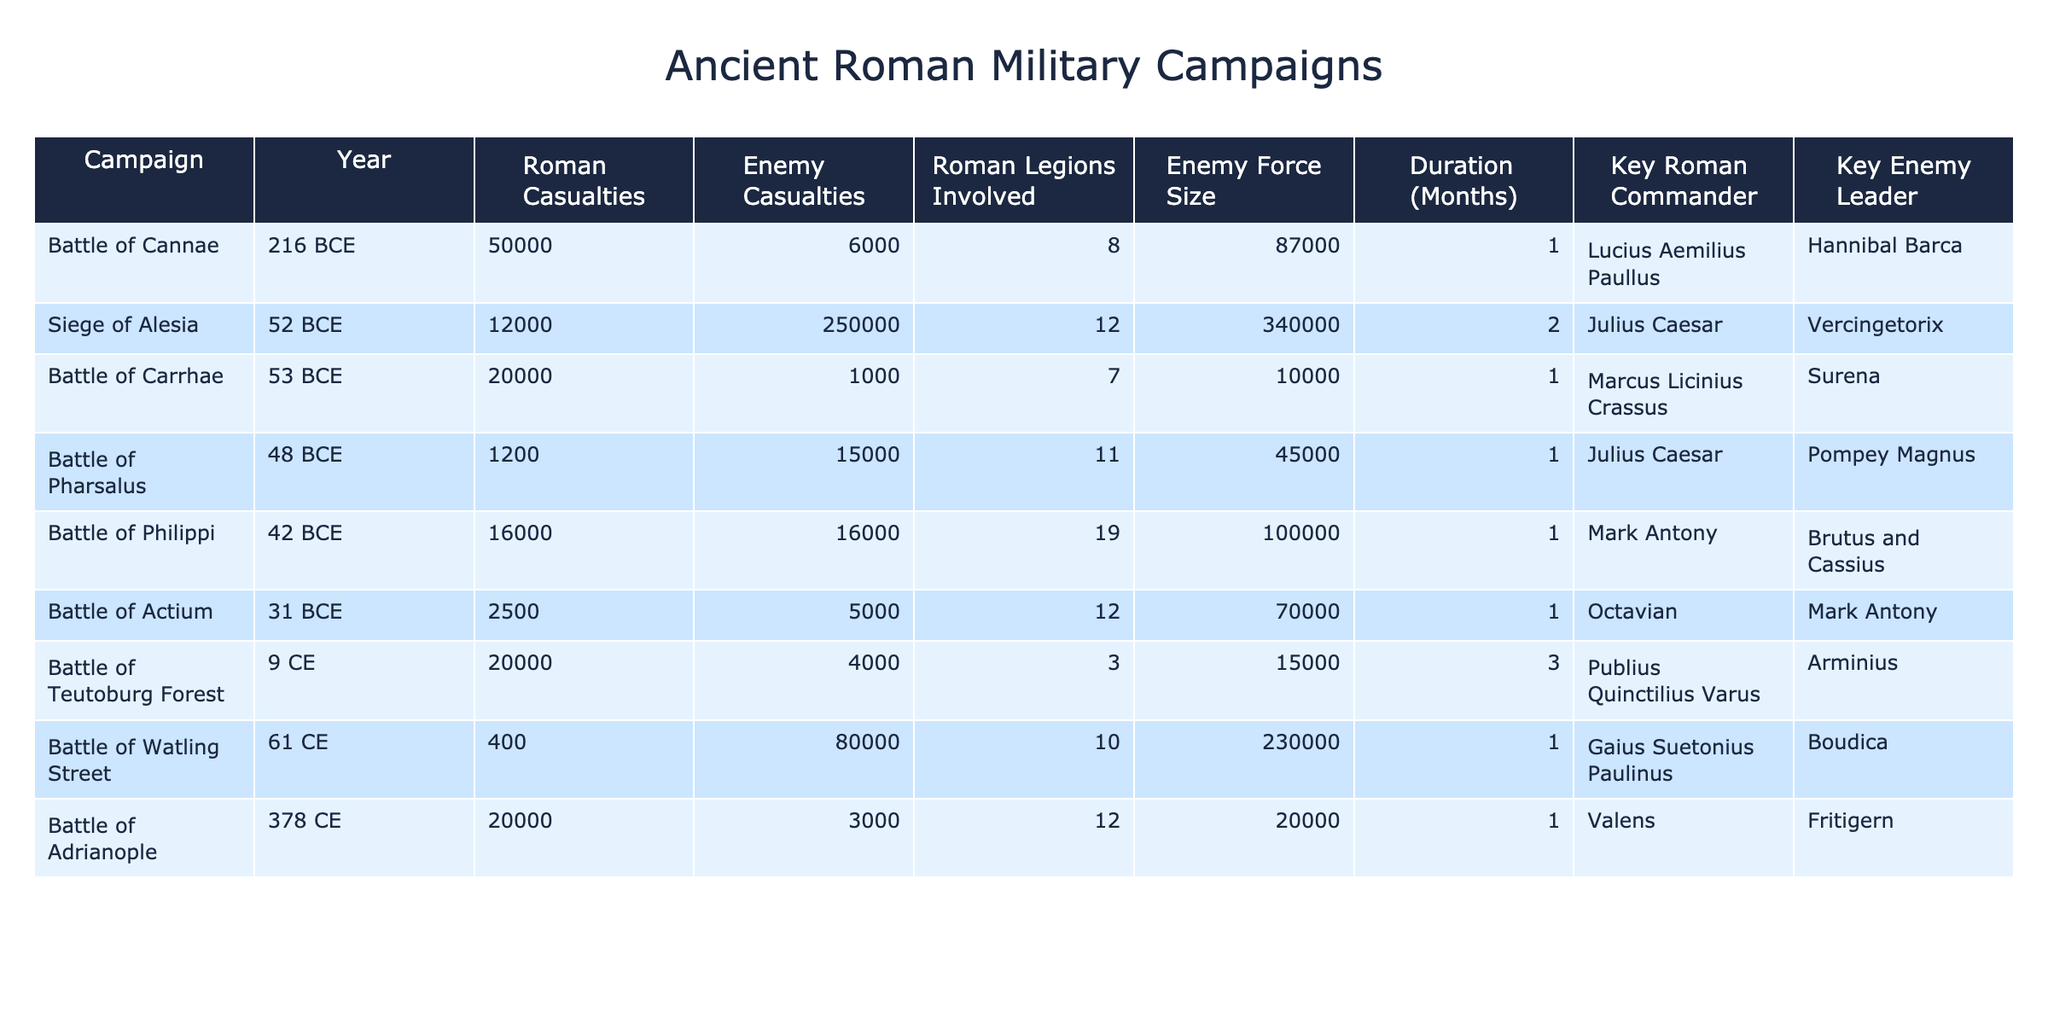What was the highest number of Roman casualties in a single campaign? By inspecting the table, the highest number of Roman casualties listed is 50,000 during the Battle of Cannae in 216 BCE.
Answer: 50,000 Which campaign had the largest enemy force size? The Siege of Alesia in 52 BCE had the largest enemy force size at 340,000 troops.
Answer: 340,000 How many Roman legions were involved in the Battle of Pharsalus? The table shows that 11 Roman legions were involved in the Battle of Pharsalus.
Answer: 11 What was the average number of enemy casualties across all campaigns? To find the average, we sum the enemy casualties: (6000 + 250000 + 1000 + 15000 + 16000 + 5000 + 4000 + 3000) = 263,000. There are 8 campaigns, so the average is 263,000 / 8 = 32,875.
Answer: 32,875 Did the Roman casualties in the Battle of Adrianople exceed those in the Siege of Alesia? Comparing the Roman casualties, the Battle of Adrianople had 20,000, while the Siege of Alesia had 12,000. Since 20,000 is greater than 12,000, yes, Roman casualties in the Battle of Adrianople exceeded those in the Siege of Alesia.
Answer: Yes Which campaign had the highest ratio of enemy casualties to Roman casualties? To find the highest ratio, we calculate the ratio for each campaign. The Siege of Alesia has the highest ratio of 250,000 enemy casualties to 12,000 Roman casualties, which gives a ratio of approximately 20.83.
Answer: Siege of Alesia What was the duration of the Battle of Teutoburg Forest? The table indicates that the duration of the Battle of Teutoburg Forest was 3 months.
Answer: 3 months Which Roman commander experienced the fewest casualties in their campaign? Looking through the table, the commander with the fewest Roman casualties is Gaius Suetonius Paulinus during the Battle of Watling Street, with only 400 casualties.
Answer: Gaius Suetonius Paulinus What percentage of enemy forces were lost in the Battle of Carrhae? The enemy casualties were 1,000, and the enemy force size was 10,000, yielding a percentage of lost forces of (1,000 / 10,000) * 100 = 10%.
Answer: 10% In which campaigns did a Roman commander face a greater number of enemy casualties than Roman casualties? By checking the table, the campaigns where enemy casualties exceeded Roman casualties are the Siege of Alesia, Battle of Watling Street, and Battle of Philippi.
Answer: 3 campaigns 